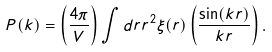Convert formula to latex. <formula><loc_0><loc_0><loc_500><loc_500>P ( k ) = \left ( \frac { 4 \pi } { V } \right ) \int d r r ^ { 2 } \xi ( r ) \left ( \frac { \sin ( k r ) } { k r } \right ) .</formula> 